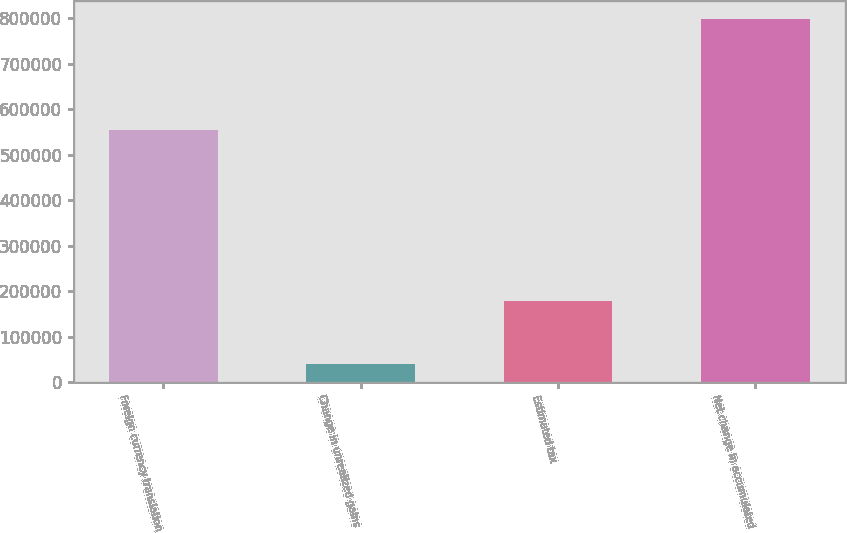Convert chart. <chart><loc_0><loc_0><loc_500><loc_500><bar_chart><fcel>Foreign currency translation<fcel>Change in unrealized gains<fcel>Estimated tax<fcel>Net change in accumulated<nl><fcel>553490<fcel>40522<fcel>179348<fcel>797791<nl></chart> 